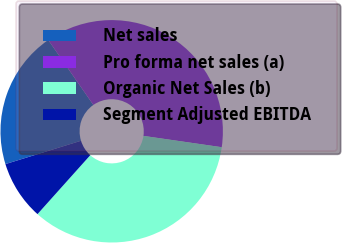<chart> <loc_0><loc_0><loc_500><loc_500><pie_chart><fcel>Net sales<fcel>Pro forma net sales (a)<fcel>Organic Net Sales (b)<fcel>Segment Adjusted EBITDA<nl><fcel>20.1%<fcel>36.95%<fcel>34.34%<fcel>8.61%<nl></chart> 